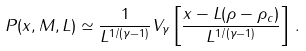<formula> <loc_0><loc_0><loc_500><loc_500>P ( x , M , L ) \simeq \frac { 1 } { L ^ { 1 / ( \gamma - 1 ) } } V _ { \gamma } \left [ \frac { x - L ( \rho - \rho _ { c } ) } { L ^ { 1 / ( \gamma - 1 ) } } \right ] \, .</formula> 